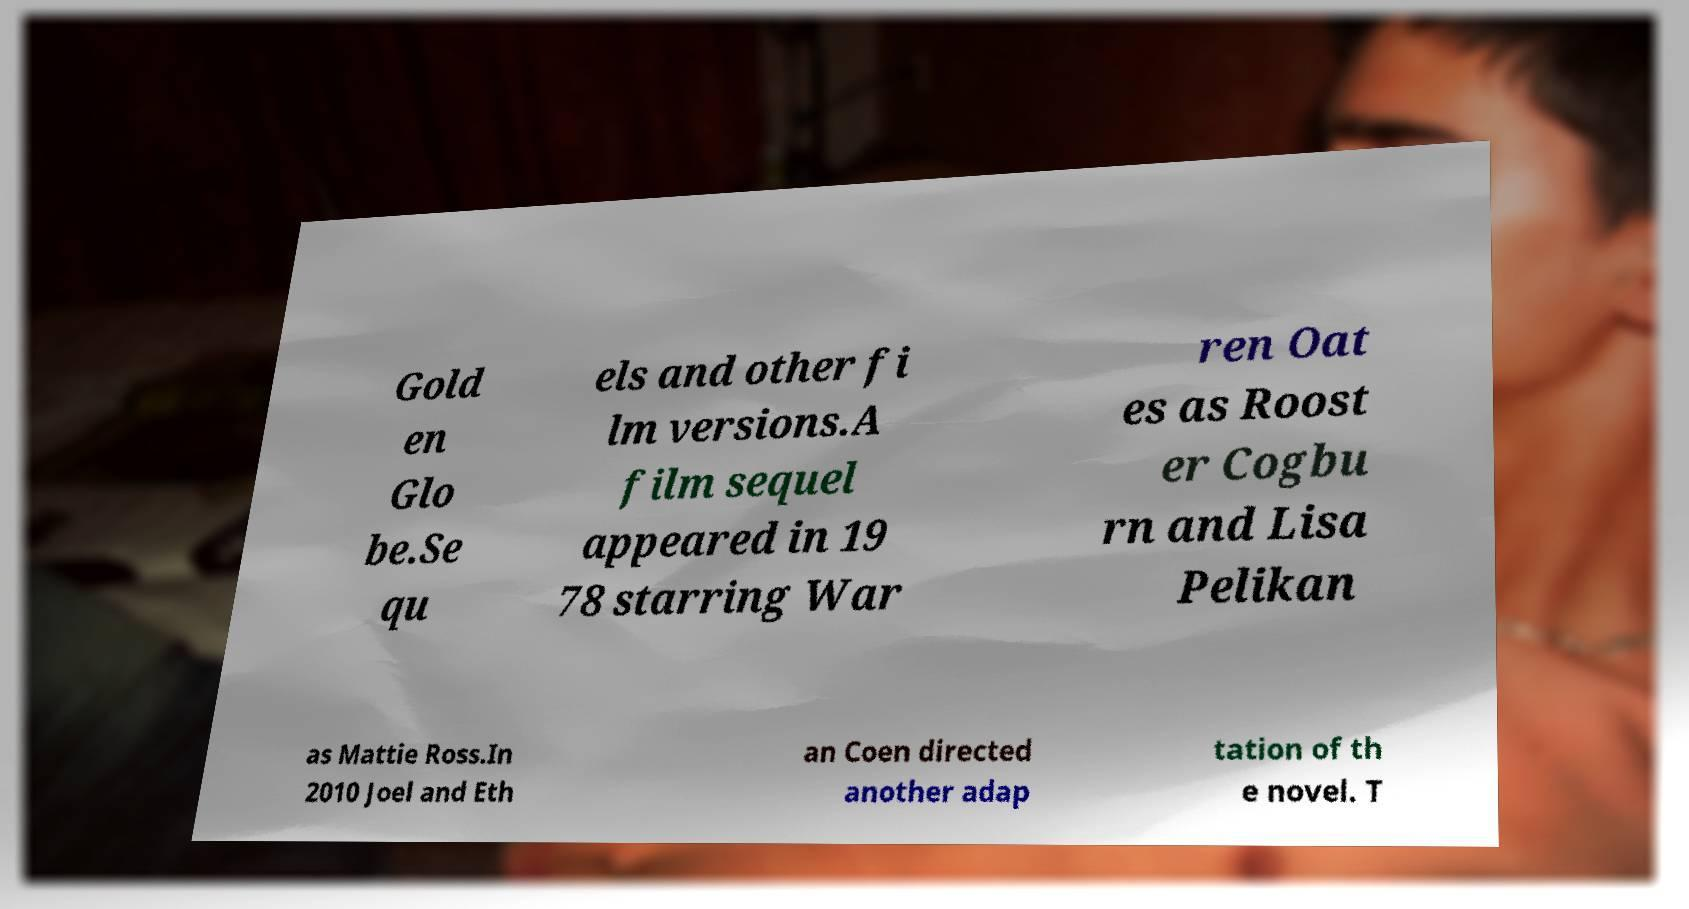Could you extract and type out the text from this image? Gold en Glo be.Se qu els and other fi lm versions.A film sequel appeared in 19 78 starring War ren Oat es as Roost er Cogbu rn and Lisa Pelikan as Mattie Ross.In 2010 Joel and Eth an Coen directed another adap tation of th e novel. T 